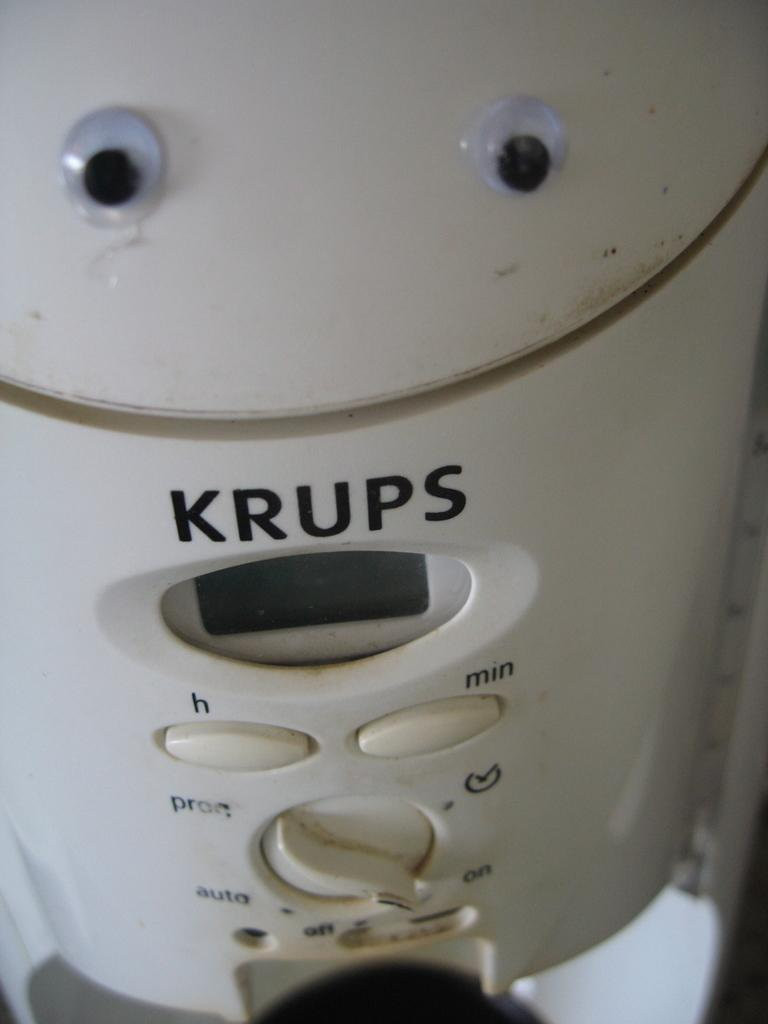What natural feature is the main subject of the image? There is a geyser in the image. Where is the nearest hospital to the geyser in the image? The image does not provide any information about the location of a hospital, nor does it show any buildings or structures that could be identified as a hospital. 